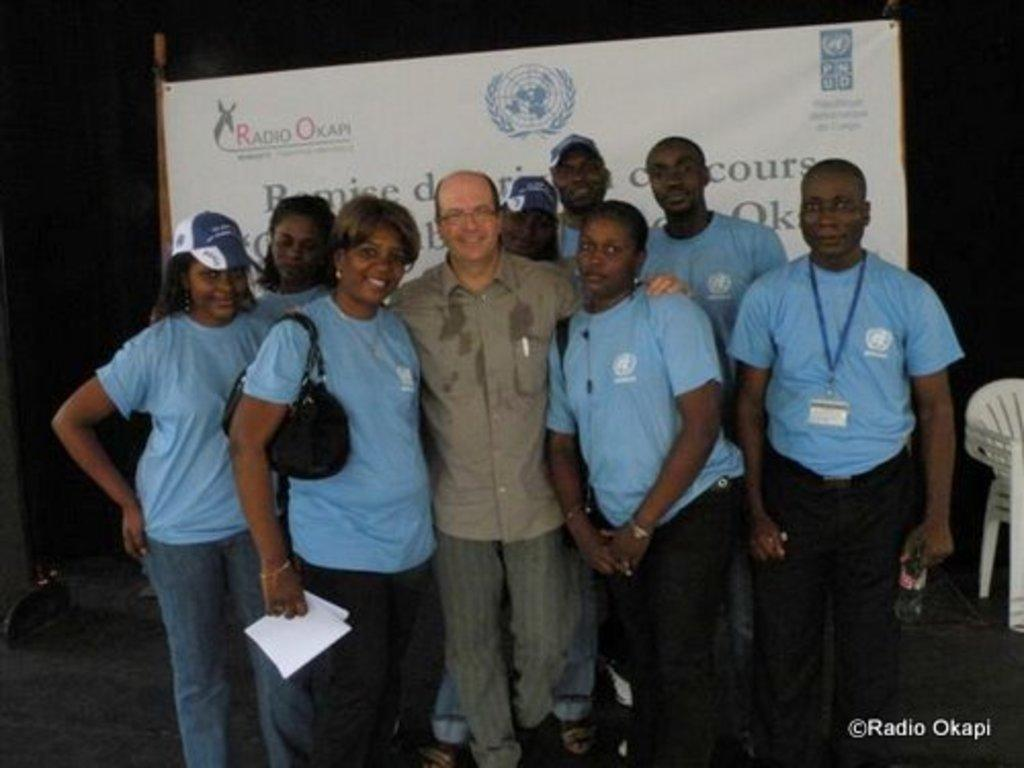What can be seen in the image? There are people standing in the image. What objects are present in the image that the people might use? There are chairs in the image. What can be found in the background of the image? There is a written text on a board in the background of the image. How many horses are present in the image? There are no horses visible in the image. What fact can be learned from the letters on the board in the image? The provided facts do not mention any specific letters or information on the board, so it is not possible to determine a fact from the image. 